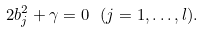Convert formula to latex. <formula><loc_0><loc_0><loc_500><loc_500>2 b ^ { 2 } _ { j } + \gamma = 0 \ ( j = 1 , \dots , l ) .</formula> 